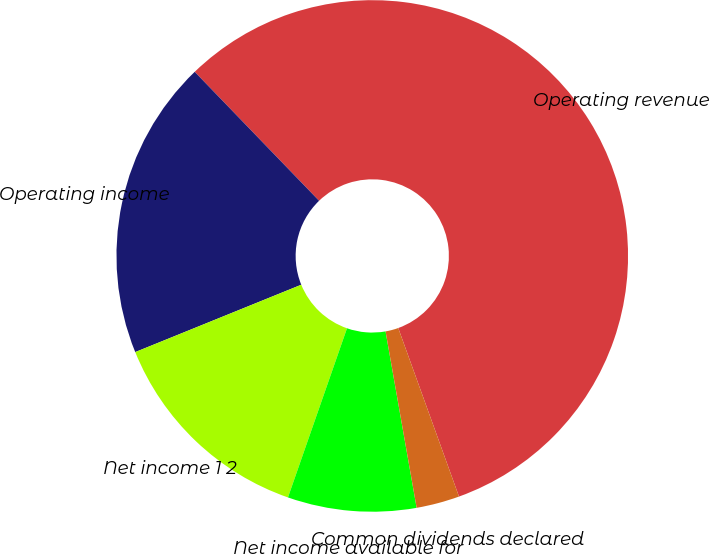Convert chart. <chart><loc_0><loc_0><loc_500><loc_500><pie_chart><fcel>Operating revenue<fcel>Operating income<fcel>Net income 1 2<fcel>Net income available for<fcel>Common dividends declared<nl><fcel>56.7%<fcel>18.92%<fcel>13.52%<fcel>8.12%<fcel>2.73%<nl></chart> 